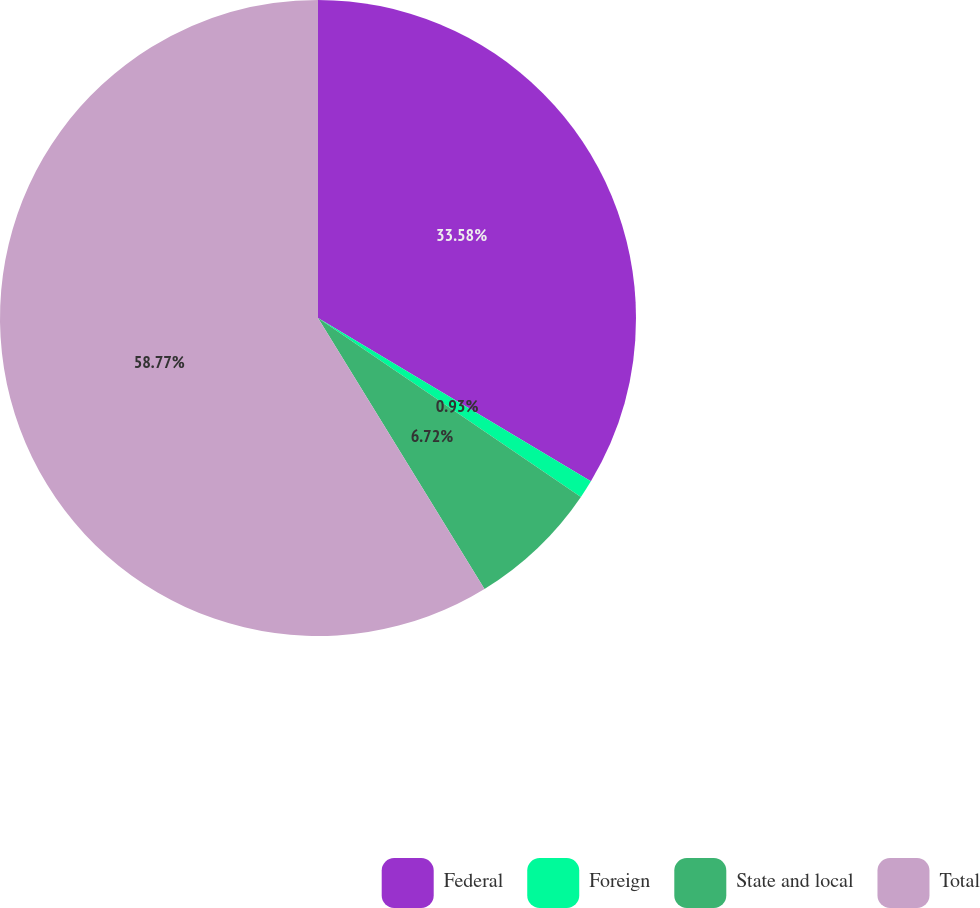Convert chart. <chart><loc_0><loc_0><loc_500><loc_500><pie_chart><fcel>Federal<fcel>Foreign<fcel>State and local<fcel>Total<nl><fcel>33.58%<fcel>0.93%<fcel>6.72%<fcel>58.77%<nl></chart> 